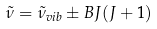Convert formula to latex. <formula><loc_0><loc_0><loc_500><loc_500>\tilde { \nu } = \tilde { \nu } _ { v i b } \pm B J ( J + 1 )</formula> 